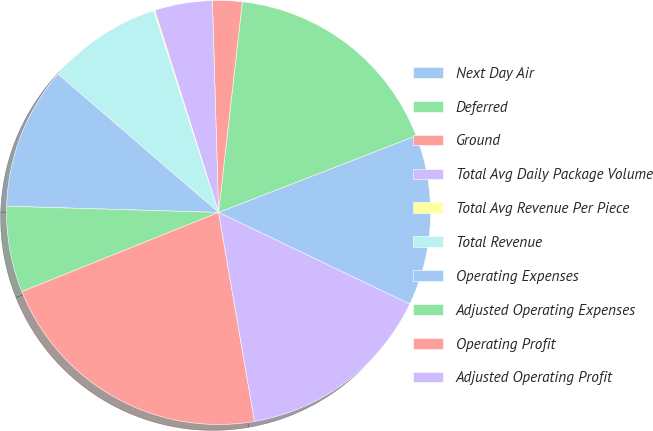<chart> <loc_0><loc_0><loc_500><loc_500><pie_chart><fcel>Next Day Air<fcel>Deferred<fcel>Ground<fcel>Total Avg Daily Package Volume<fcel>Total Avg Revenue Per Piece<fcel>Total Revenue<fcel>Operating Expenses<fcel>Adjusted Operating Expenses<fcel>Operating Profit<fcel>Adjusted Operating Profit<nl><fcel>13.01%<fcel>17.32%<fcel>2.25%<fcel>4.4%<fcel>0.1%<fcel>8.71%<fcel>10.86%<fcel>6.56%<fcel>21.62%<fcel>15.17%<nl></chart> 